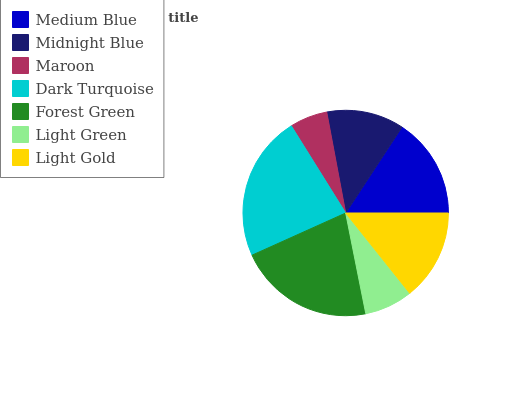Is Maroon the minimum?
Answer yes or no. Yes. Is Dark Turquoise the maximum?
Answer yes or no. Yes. Is Midnight Blue the minimum?
Answer yes or no. No. Is Midnight Blue the maximum?
Answer yes or no. No. Is Medium Blue greater than Midnight Blue?
Answer yes or no. Yes. Is Midnight Blue less than Medium Blue?
Answer yes or no. Yes. Is Midnight Blue greater than Medium Blue?
Answer yes or no. No. Is Medium Blue less than Midnight Blue?
Answer yes or no. No. Is Light Gold the high median?
Answer yes or no. Yes. Is Light Gold the low median?
Answer yes or no. Yes. Is Forest Green the high median?
Answer yes or no. No. Is Medium Blue the low median?
Answer yes or no. No. 